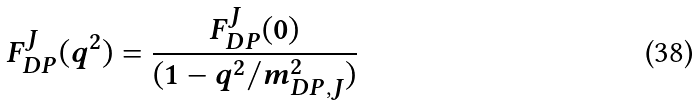<formula> <loc_0><loc_0><loc_500><loc_500>F ^ { J } _ { D P } ( q ^ { 2 } ) = \frac { F ^ { J } _ { D P } ( 0 ) } { ( 1 - q ^ { 2 } / { m ^ { 2 } _ { D P , J } } ) }</formula> 